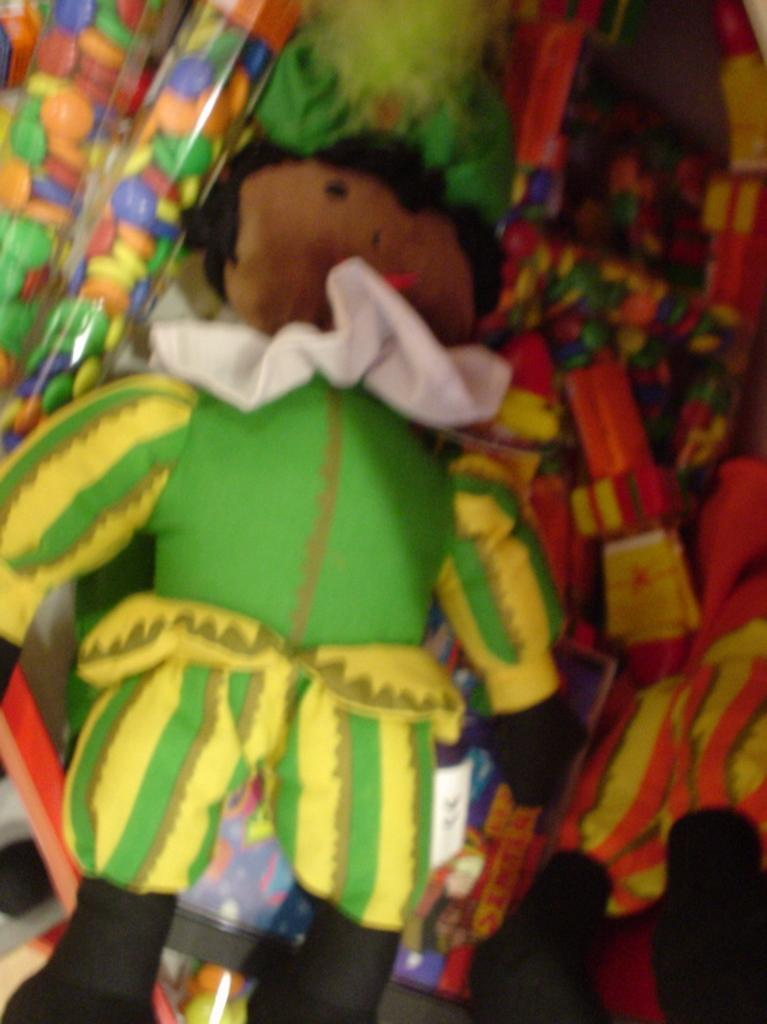What is the main subject of the image? There is a doll in the image. What colors can be seen on the doll? The doll has green, yellow, black, and brown colors. What else is present in the image besides the doll? There are colorful toys around the doll. What direction is the doll facing in the image? The facts provided do not mention the direction the doll is facing, so we cannot determine that information from the image. 